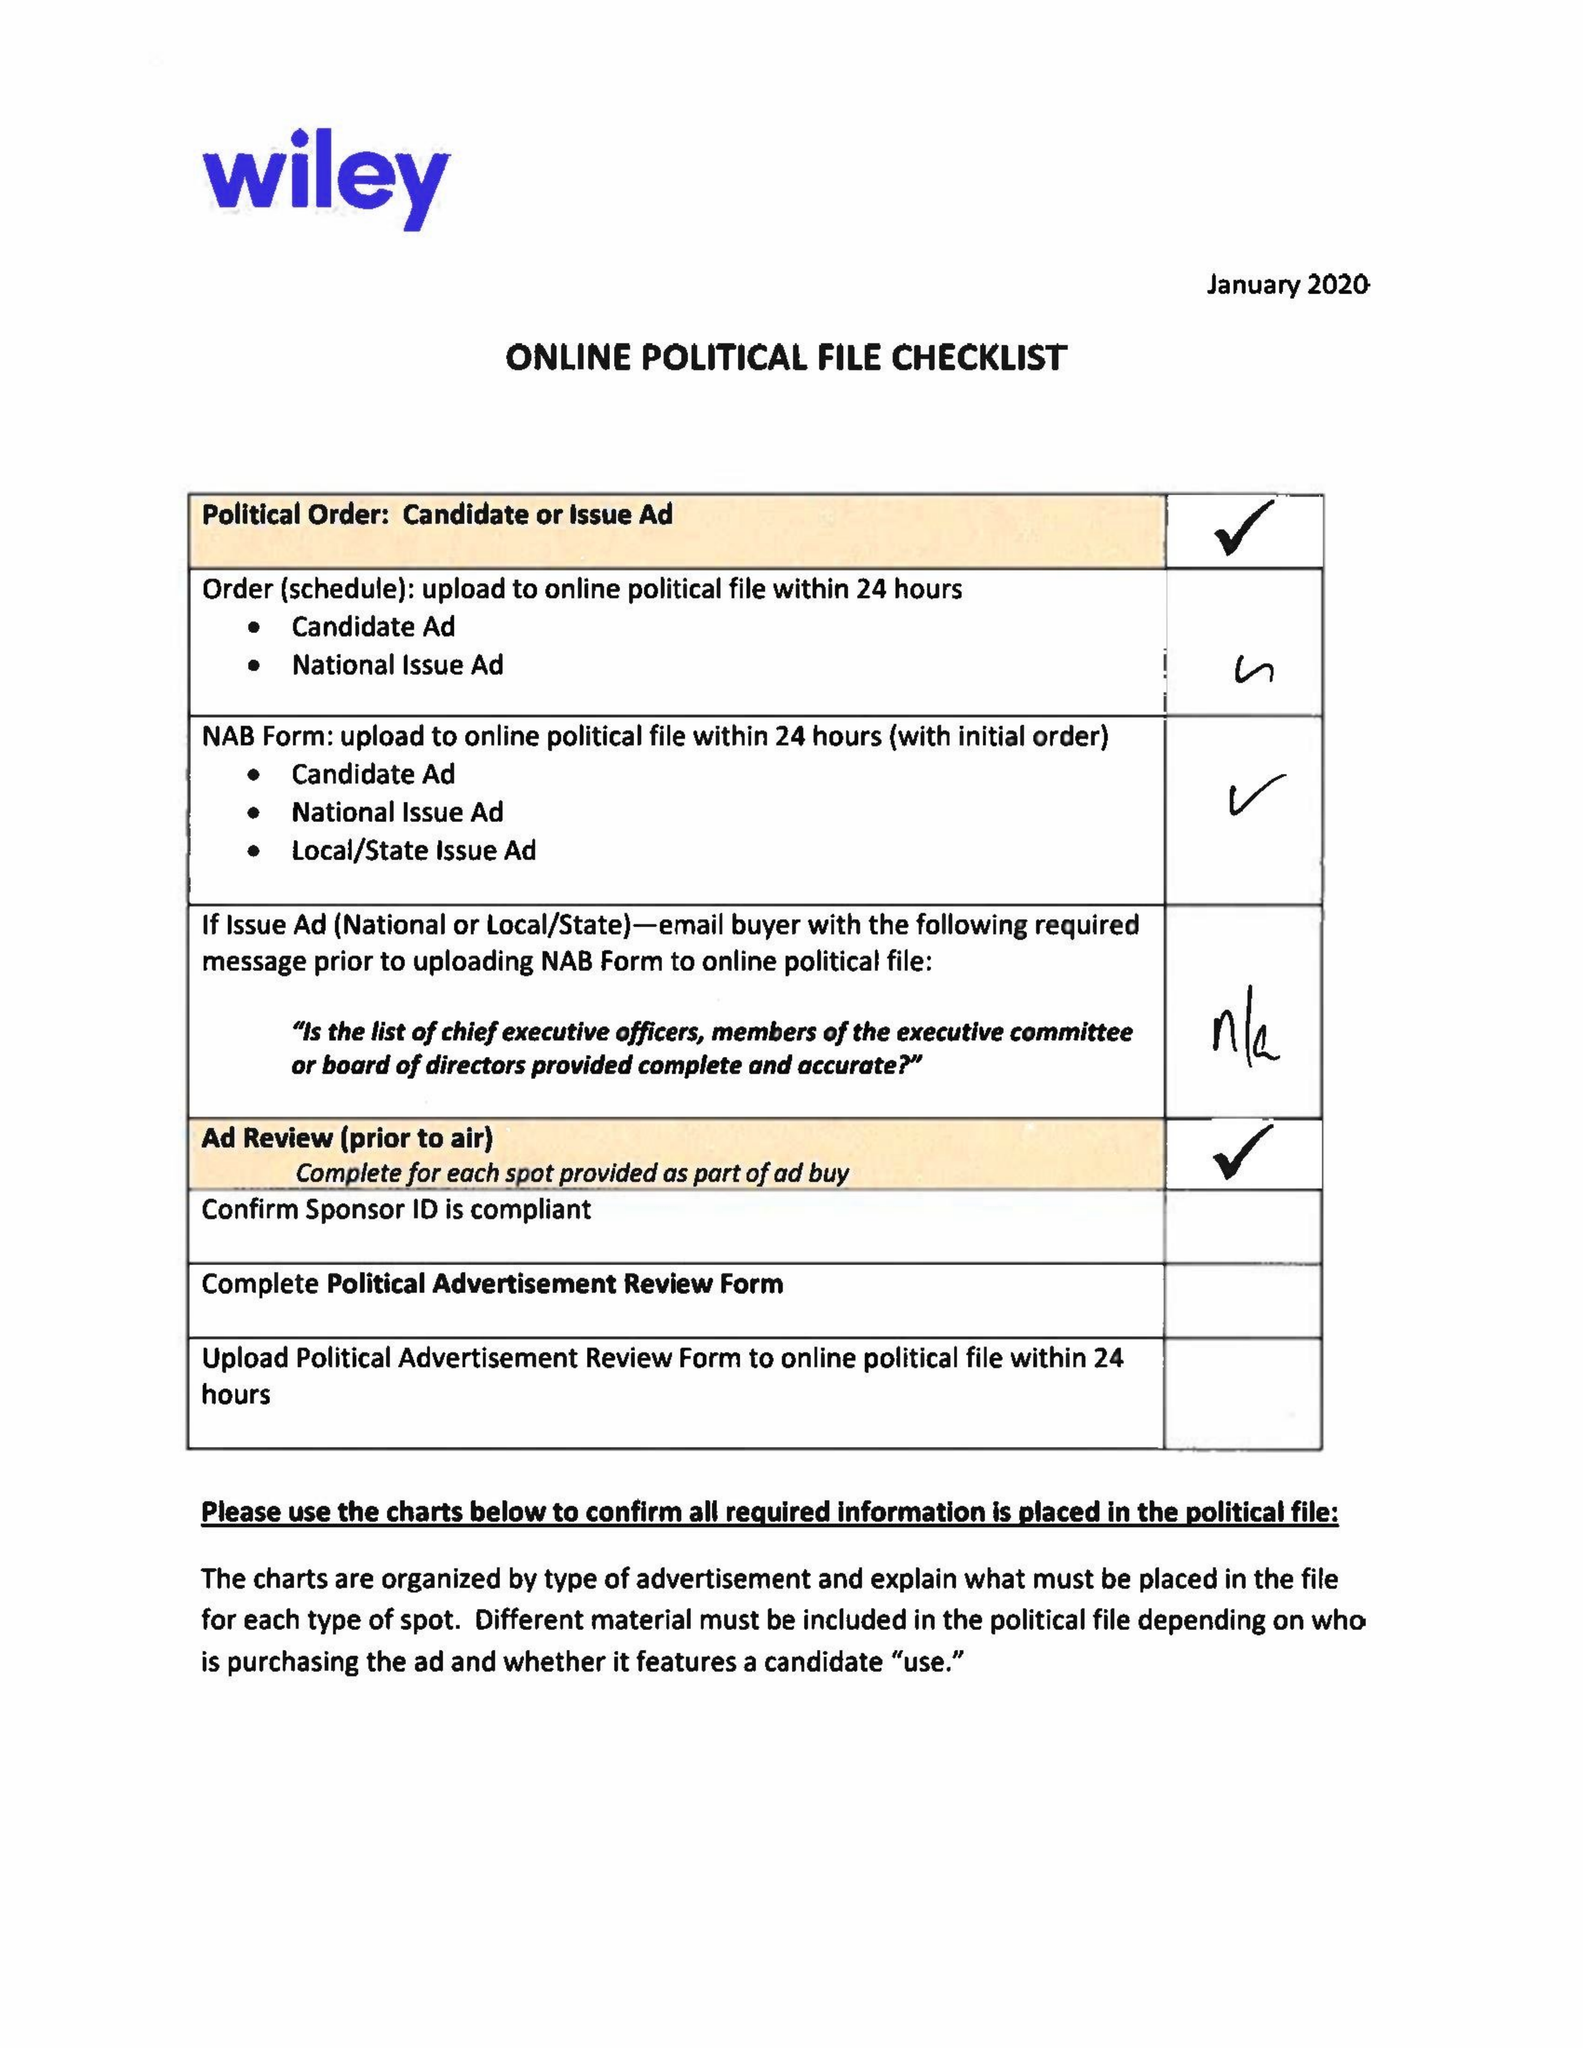What is the value for the flight_to?
Answer the question using a single word or phrase. 03/02/20 